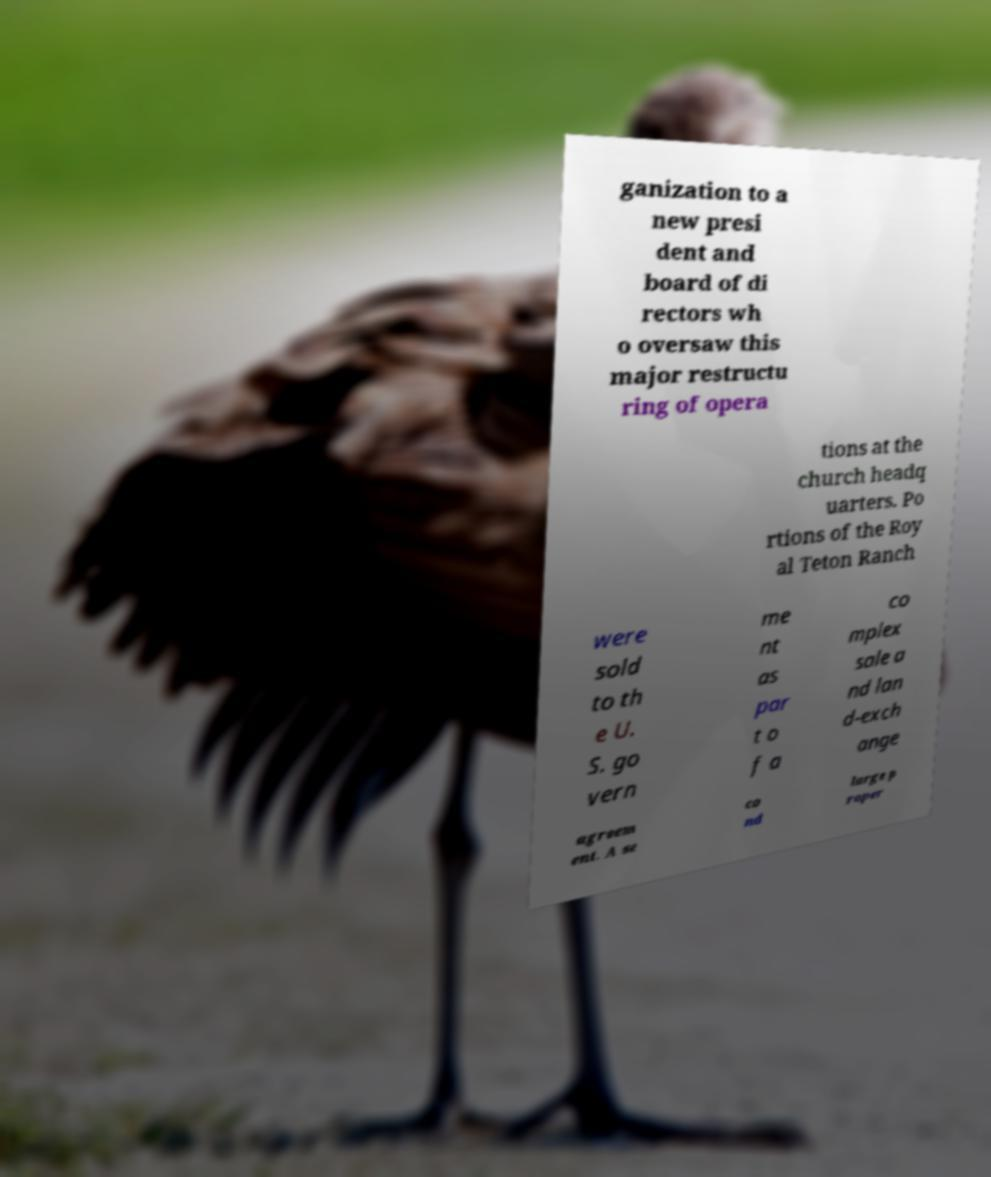Can you accurately transcribe the text from the provided image for me? ganization to a new presi dent and board of di rectors wh o oversaw this major restructu ring of opera tions at the church headq uarters. Po rtions of the Roy al Teton Ranch were sold to th e U. S. go vern me nt as par t o f a co mplex sale a nd lan d-exch ange agreem ent. A se co nd large p roper 